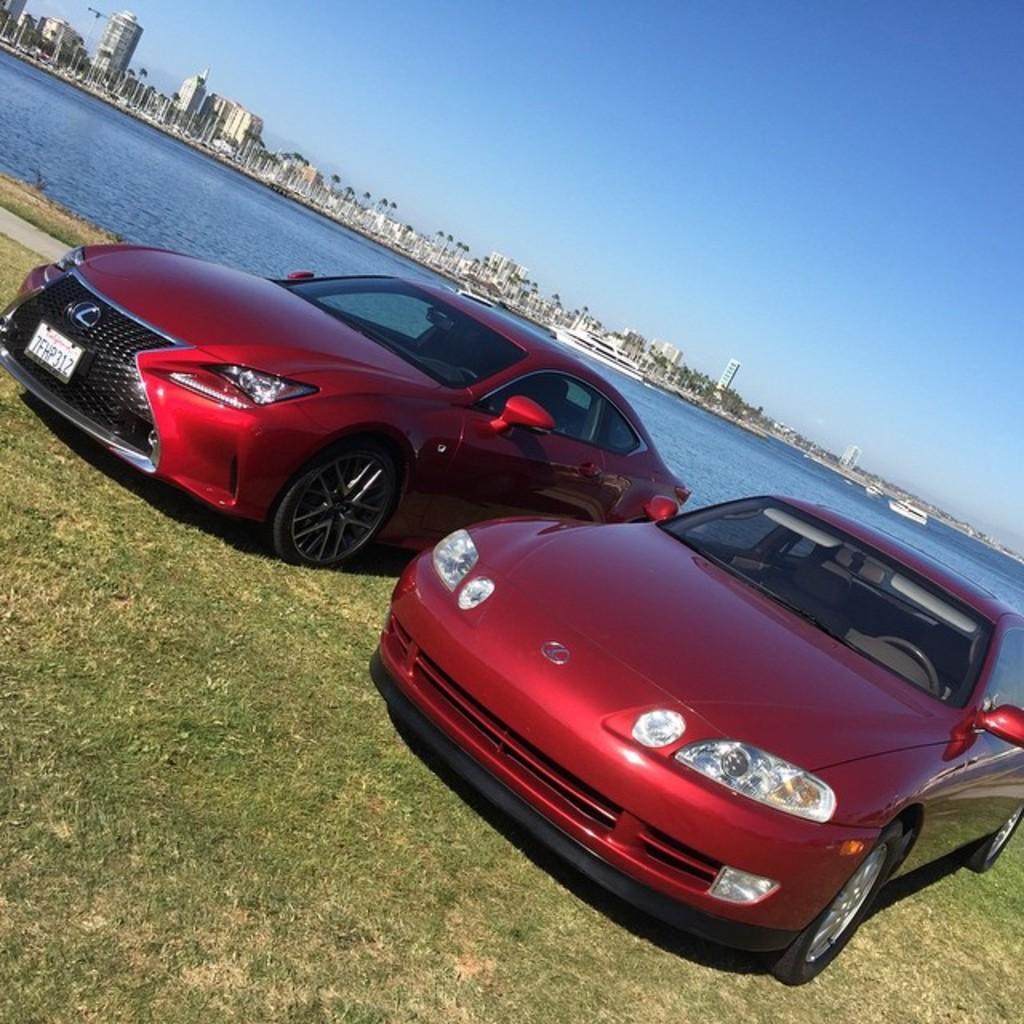Please provide a concise description of this image. In the center of the image there are cars which are in red color. In the background there is a river, buildings and sky. At the bottom we can see grass. 